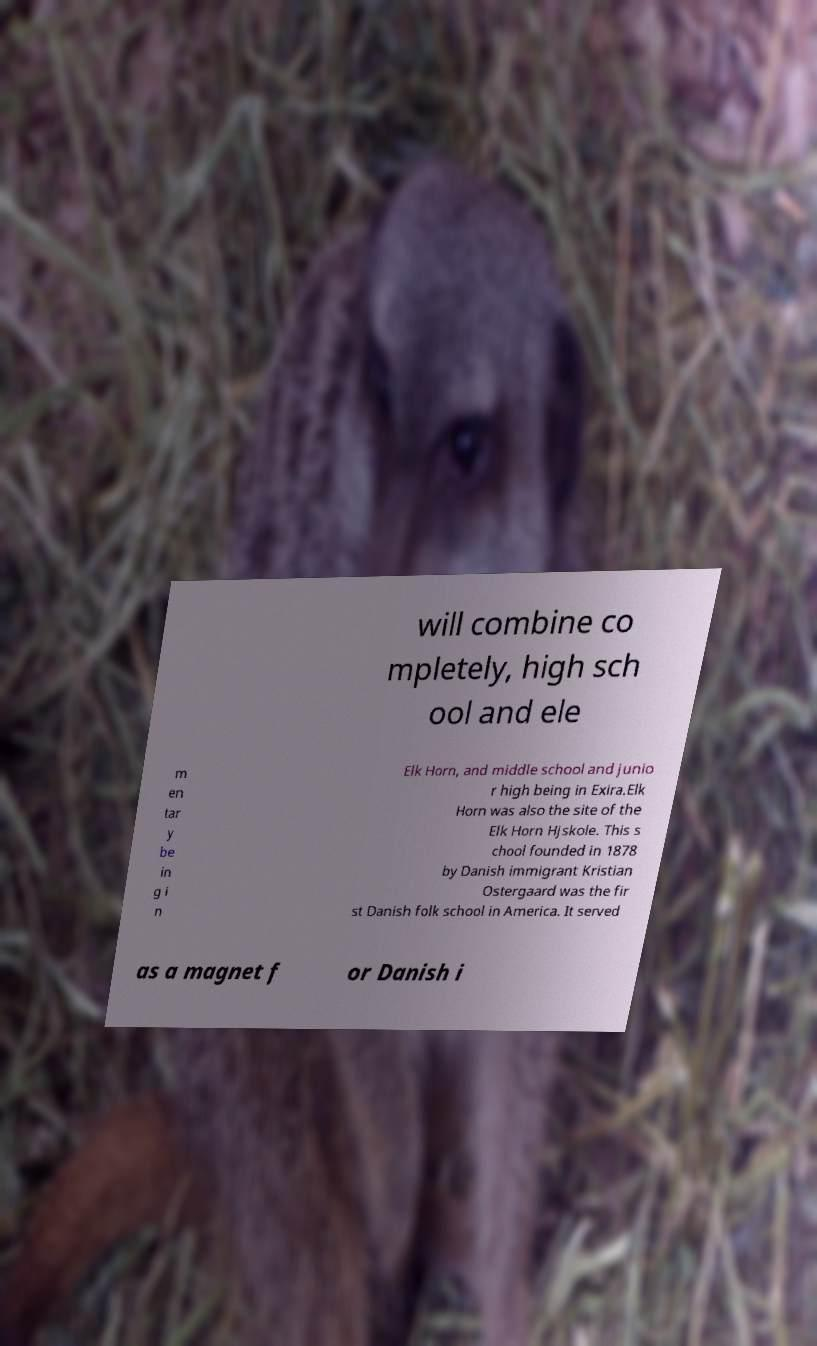Can you read and provide the text displayed in the image?This photo seems to have some interesting text. Can you extract and type it out for me? will combine co mpletely, high sch ool and ele m en tar y be in g i n Elk Horn, and middle school and junio r high being in Exira.Elk Horn was also the site of the Elk Horn Hjskole. This s chool founded in 1878 by Danish immigrant Kristian Ostergaard was the fir st Danish folk school in America. It served as a magnet f or Danish i 